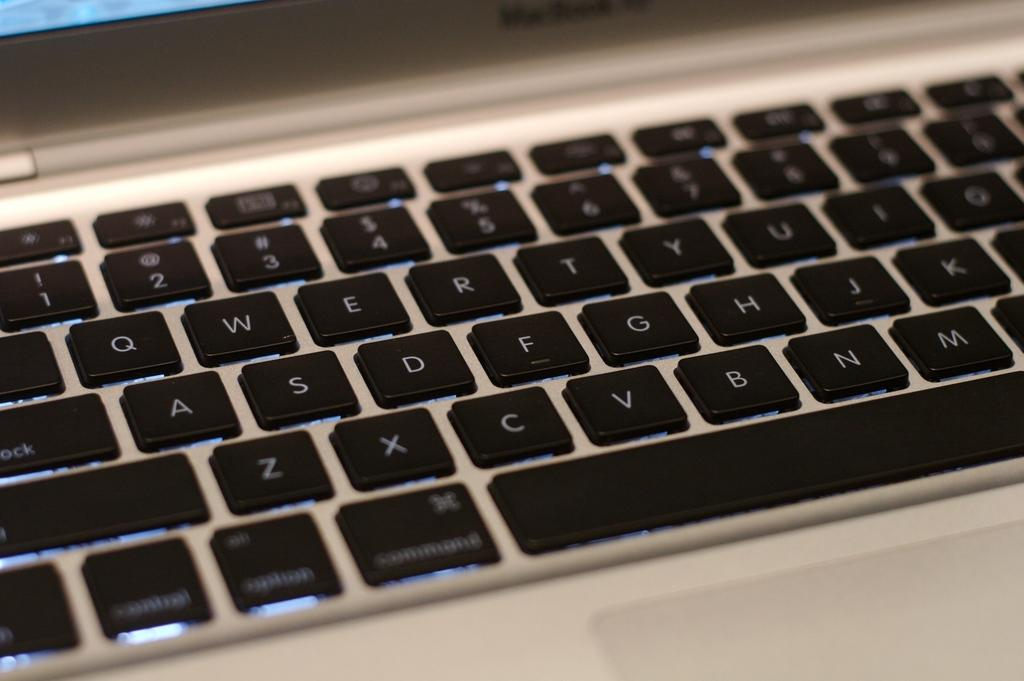<image>
Provide a brief description of the given image. A laptop computer open with the keys showing, some of the letters are z,x,c,v,b and M 